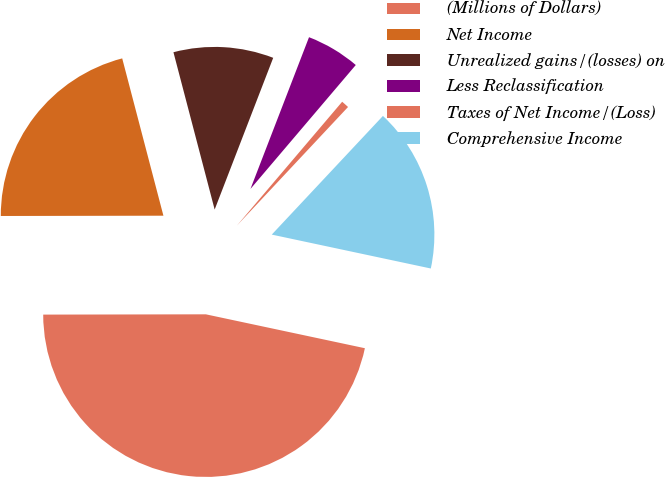Convert chart to OTSL. <chart><loc_0><loc_0><loc_500><loc_500><pie_chart><fcel>(Millions of Dollars)<fcel>Net Income<fcel>Unrealized gains/(losses) on<fcel>Less Reclassification<fcel>Taxes of Net Income/(Loss)<fcel>Comprehensive Income<nl><fcel>46.63%<fcel>20.95%<fcel>9.94%<fcel>5.35%<fcel>0.77%<fcel>16.36%<nl></chart> 